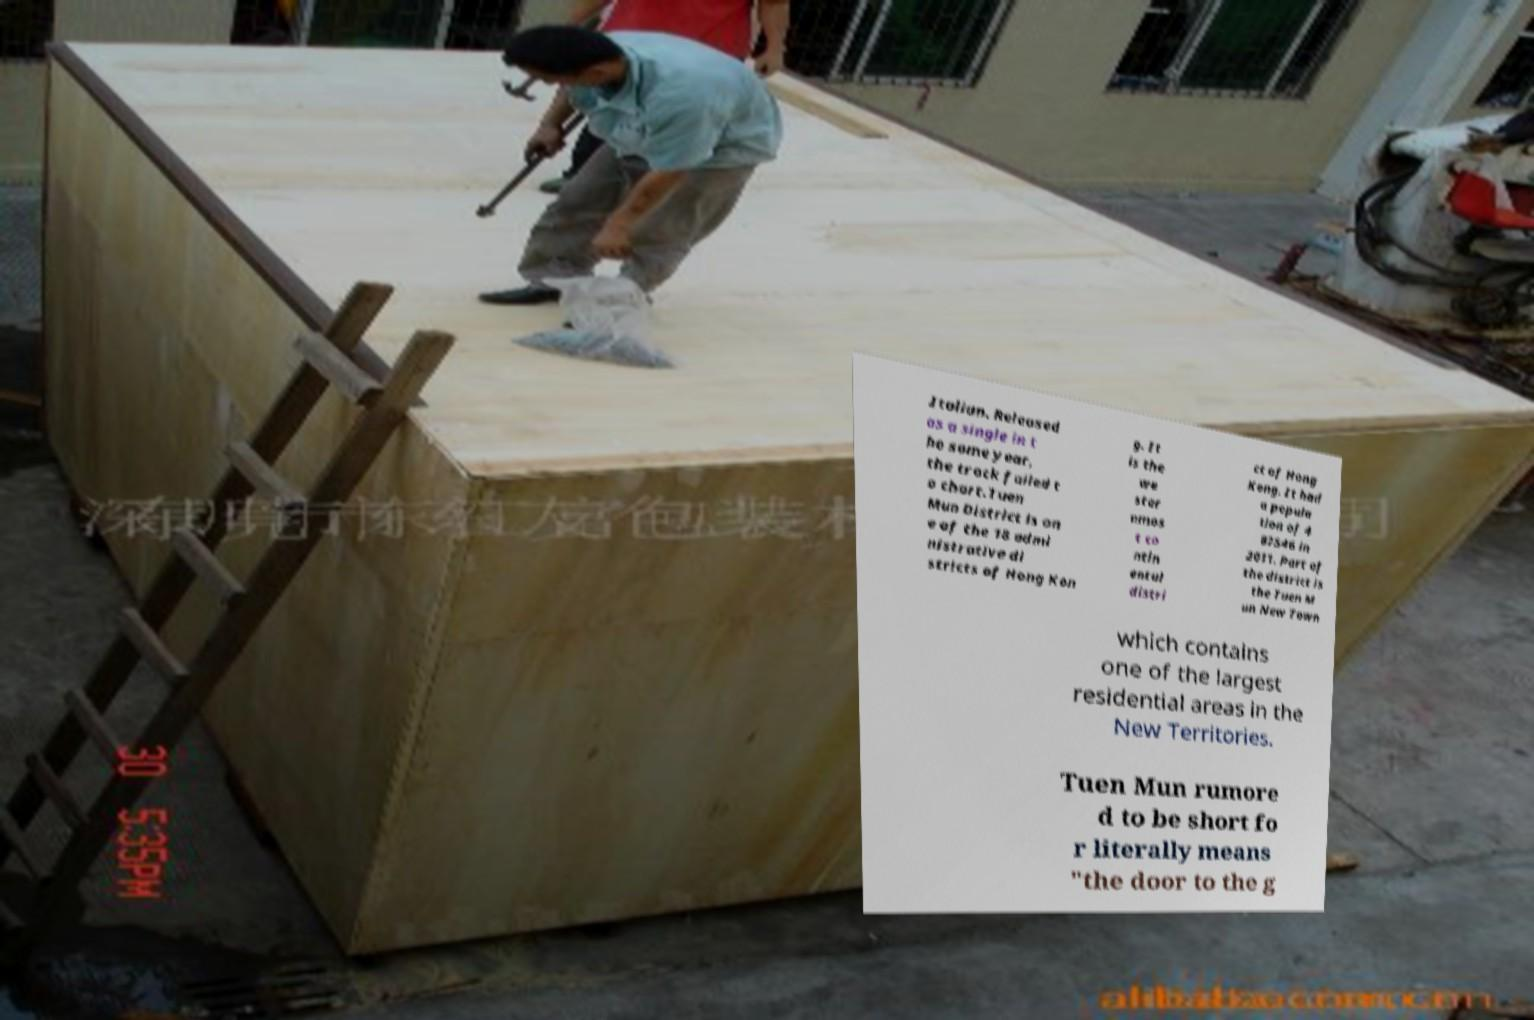Please identify and transcribe the text found in this image. Italian. Released as a single in t he same year, the track failed t o chart.Tuen Mun District is on e of the 18 admi nistrative di stricts of Hong Kon g. It is the we ster nmos t co ntin ental distri ct of Hong Kong. It had a popula tion of 4 87546 in 2011. Part of the district is the Tuen M un New Town which contains one of the largest residential areas in the New Territories. Tuen Mun rumore d to be short fo r literally means "the door to the g 